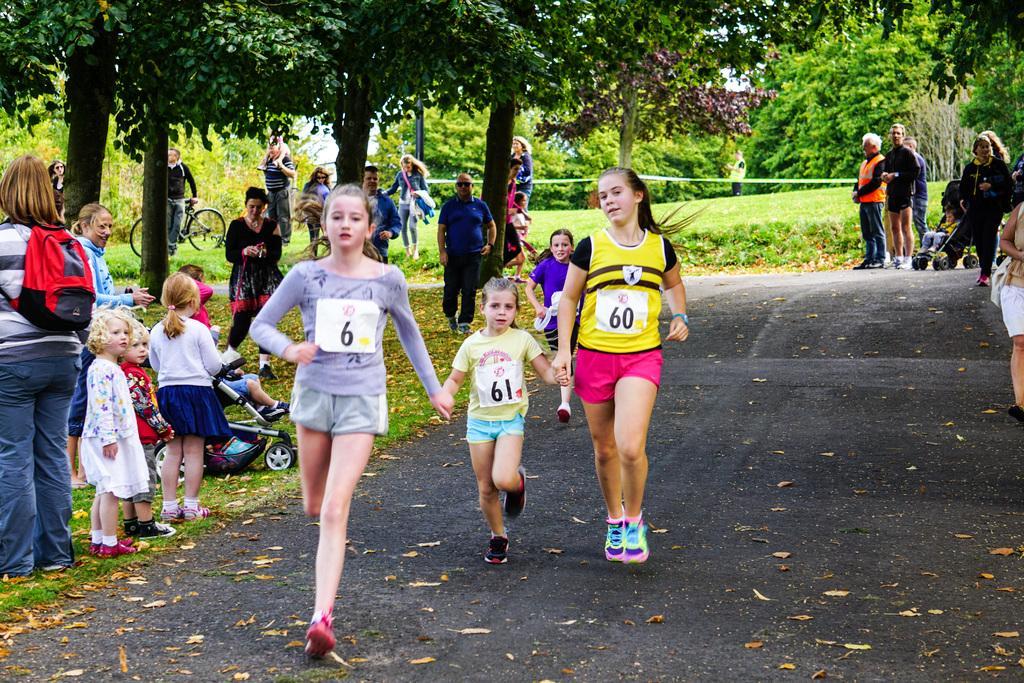How would you summarize this image in a sentence or two? This is the picture of a park. In this image there are four persons running on the road. At the back there are group of people standing. On the left side of the image there is a baby sitting in the baby traveler and the person with black t-shirt is holding the bicycle. At the back there are trees and there is a pole. At the top there is sky. At the bottom there is a road and there is grass. 